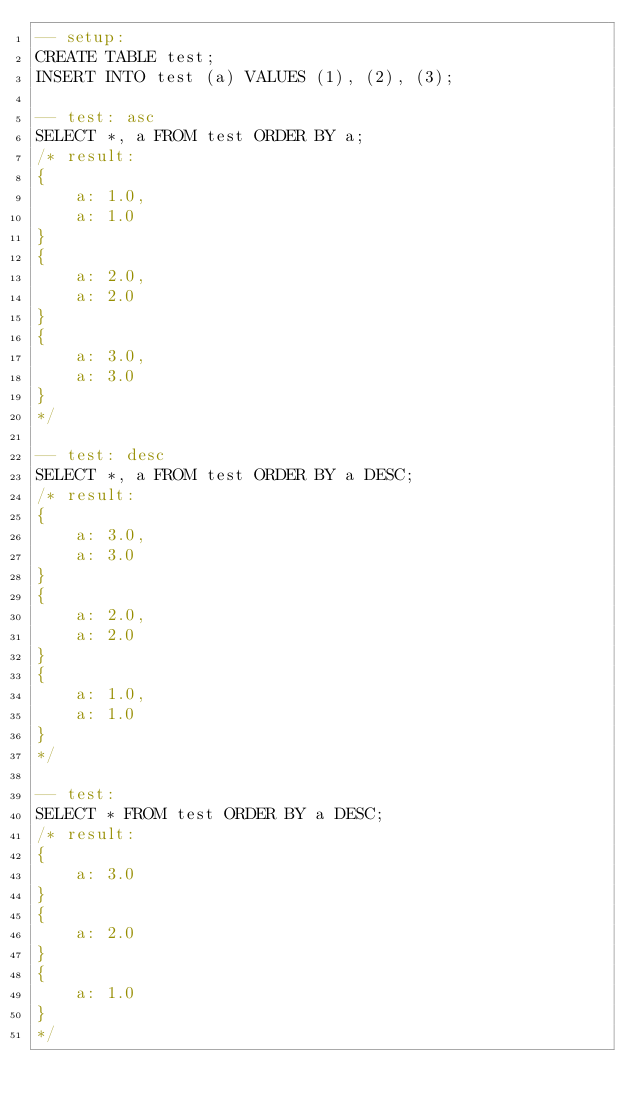<code> <loc_0><loc_0><loc_500><loc_500><_SQL_>-- setup:
CREATE TABLE test;
INSERT INTO test (a) VALUES (1), (2), (3);

-- test: asc
SELECT *, a FROM test ORDER BY a;
/* result:
{
    a: 1.0,
    a: 1.0
}
{
    a: 2.0,
    a: 2.0
}
{
    a: 3.0,
    a: 3.0
}
*/

-- test: desc
SELECT *, a FROM test ORDER BY a DESC;
/* result:
{
    a: 3.0,
    a: 3.0
}
{
    a: 2.0,
    a: 2.0
}
{
    a: 1.0,
    a: 1.0
}
*/

-- test: 
SELECT * FROM test ORDER BY a DESC;
/* result:
{
    a: 3.0
}
{
    a: 2.0
}
{
    a: 1.0
}
*/</code> 